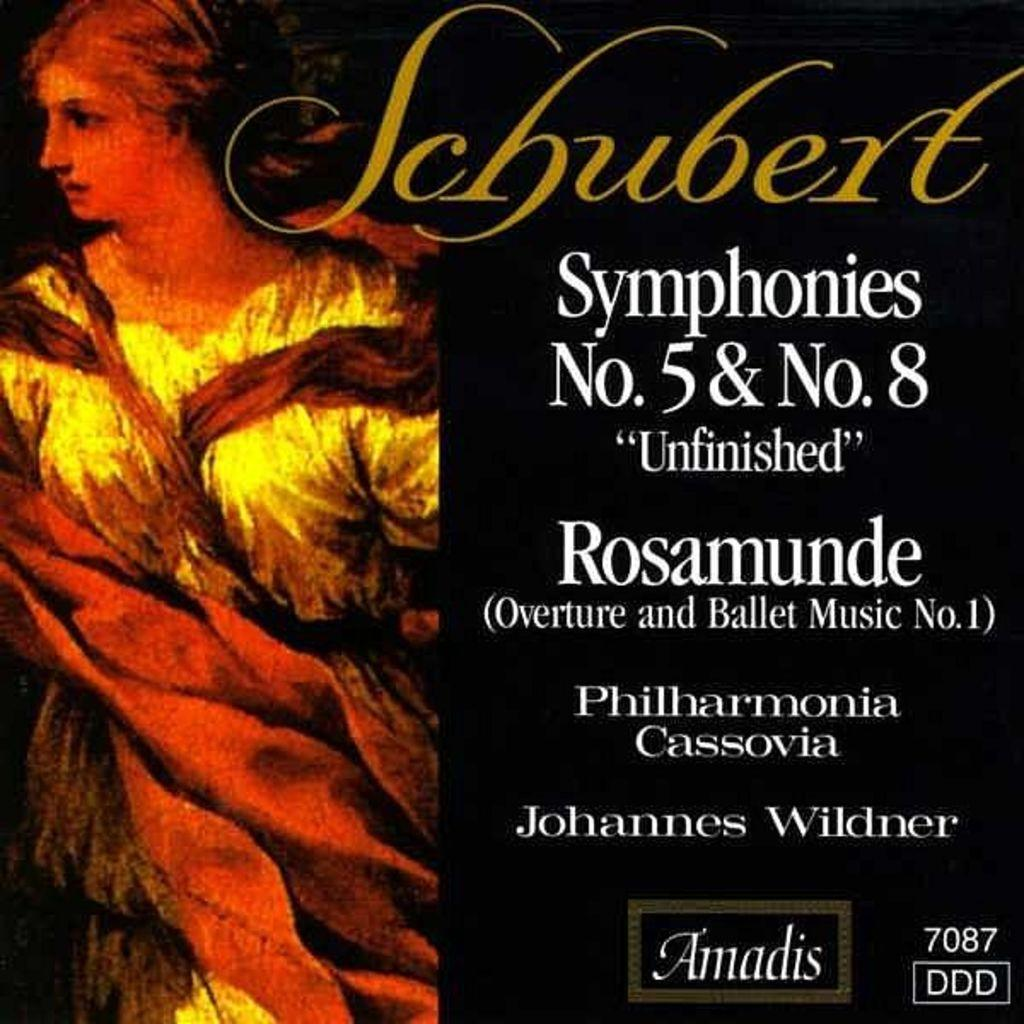Provide a one-sentence caption for the provided image. An album cover for Schubert Symphonies No. 5 & No. 8. 